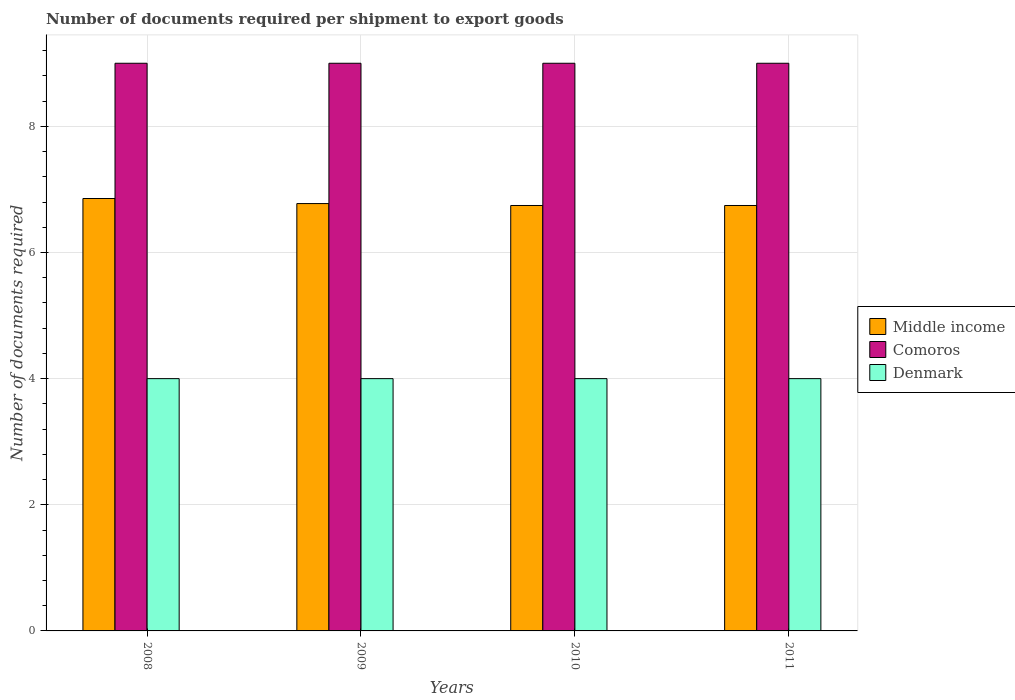How many different coloured bars are there?
Offer a very short reply. 3. How many groups of bars are there?
Ensure brevity in your answer.  4. Are the number of bars on each tick of the X-axis equal?
Ensure brevity in your answer.  Yes. How many bars are there on the 4th tick from the left?
Provide a succinct answer. 3. What is the label of the 1st group of bars from the left?
Your answer should be compact. 2008. What is the number of documents required per shipment to export goods in Denmark in 2009?
Provide a short and direct response. 4. Across all years, what is the maximum number of documents required per shipment to export goods in Middle income?
Your answer should be very brief. 6.86. Across all years, what is the minimum number of documents required per shipment to export goods in Denmark?
Your response must be concise. 4. In which year was the number of documents required per shipment to export goods in Middle income maximum?
Provide a succinct answer. 2008. What is the total number of documents required per shipment to export goods in Comoros in the graph?
Your answer should be very brief. 36. What is the difference between the number of documents required per shipment to export goods in Comoros in 2008 and the number of documents required per shipment to export goods in Denmark in 2009?
Your response must be concise. 5. What is the average number of documents required per shipment to export goods in Comoros per year?
Your response must be concise. 9. In the year 2009, what is the difference between the number of documents required per shipment to export goods in Middle income and number of documents required per shipment to export goods in Denmark?
Keep it short and to the point. 2.78. In how many years, is the number of documents required per shipment to export goods in Middle income greater than 2.4?
Your answer should be very brief. 4. What is the ratio of the number of documents required per shipment to export goods in Comoros in 2008 to that in 2009?
Your response must be concise. 1. What is the difference between the highest and the lowest number of documents required per shipment to export goods in Denmark?
Give a very brief answer. 0. What does the 1st bar from the right in 2011 represents?
Ensure brevity in your answer.  Denmark. How many bars are there?
Keep it short and to the point. 12. Are all the bars in the graph horizontal?
Offer a terse response. No. Are the values on the major ticks of Y-axis written in scientific E-notation?
Your response must be concise. No. How many legend labels are there?
Ensure brevity in your answer.  3. How are the legend labels stacked?
Offer a very short reply. Vertical. What is the title of the graph?
Provide a succinct answer. Number of documents required per shipment to export goods. What is the label or title of the Y-axis?
Ensure brevity in your answer.  Number of documents required. What is the Number of documents required in Middle income in 2008?
Keep it short and to the point. 6.86. What is the Number of documents required in Denmark in 2008?
Give a very brief answer. 4. What is the Number of documents required of Middle income in 2009?
Give a very brief answer. 6.78. What is the Number of documents required of Comoros in 2009?
Offer a terse response. 9. What is the Number of documents required of Denmark in 2009?
Ensure brevity in your answer.  4. What is the Number of documents required in Middle income in 2010?
Your answer should be very brief. 6.74. What is the Number of documents required of Comoros in 2010?
Provide a succinct answer. 9. What is the Number of documents required in Denmark in 2010?
Keep it short and to the point. 4. What is the Number of documents required of Middle income in 2011?
Provide a succinct answer. 6.74. Across all years, what is the maximum Number of documents required of Middle income?
Offer a terse response. 6.86. Across all years, what is the maximum Number of documents required in Comoros?
Offer a terse response. 9. Across all years, what is the minimum Number of documents required in Middle income?
Provide a succinct answer. 6.74. Across all years, what is the minimum Number of documents required of Denmark?
Offer a terse response. 4. What is the total Number of documents required of Middle income in the graph?
Provide a succinct answer. 27.12. What is the difference between the Number of documents required of Middle income in 2008 and that in 2009?
Keep it short and to the point. 0.08. What is the difference between the Number of documents required in Middle income in 2008 and that in 2010?
Offer a very short reply. 0.11. What is the difference between the Number of documents required in Comoros in 2008 and that in 2010?
Your answer should be compact. 0. What is the difference between the Number of documents required of Middle income in 2008 and that in 2011?
Make the answer very short. 0.11. What is the difference between the Number of documents required in Comoros in 2008 and that in 2011?
Your response must be concise. 0. What is the difference between the Number of documents required of Denmark in 2008 and that in 2011?
Keep it short and to the point. 0. What is the difference between the Number of documents required in Middle income in 2009 and that in 2010?
Your answer should be very brief. 0.03. What is the difference between the Number of documents required of Denmark in 2009 and that in 2010?
Ensure brevity in your answer.  0. What is the difference between the Number of documents required of Middle income in 2009 and that in 2011?
Keep it short and to the point. 0.03. What is the difference between the Number of documents required of Denmark in 2010 and that in 2011?
Make the answer very short. 0. What is the difference between the Number of documents required in Middle income in 2008 and the Number of documents required in Comoros in 2009?
Offer a very short reply. -2.14. What is the difference between the Number of documents required in Middle income in 2008 and the Number of documents required in Denmark in 2009?
Offer a very short reply. 2.86. What is the difference between the Number of documents required of Middle income in 2008 and the Number of documents required of Comoros in 2010?
Offer a very short reply. -2.14. What is the difference between the Number of documents required in Middle income in 2008 and the Number of documents required in Denmark in 2010?
Provide a short and direct response. 2.86. What is the difference between the Number of documents required in Middle income in 2008 and the Number of documents required in Comoros in 2011?
Your answer should be compact. -2.14. What is the difference between the Number of documents required in Middle income in 2008 and the Number of documents required in Denmark in 2011?
Provide a succinct answer. 2.86. What is the difference between the Number of documents required in Comoros in 2008 and the Number of documents required in Denmark in 2011?
Make the answer very short. 5. What is the difference between the Number of documents required of Middle income in 2009 and the Number of documents required of Comoros in 2010?
Offer a terse response. -2.22. What is the difference between the Number of documents required in Middle income in 2009 and the Number of documents required in Denmark in 2010?
Offer a terse response. 2.78. What is the difference between the Number of documents required in Comoros in 2009 and the Number of documents required in Denmark in 2010?
Provide a short and direct response. 5. What is the difference between the Number of documents required in Middle income in 2009 and the Number of documents required in Comoros in 2011?
Your answer should be very brief. -2.22. What is the difference between the Number of documents required of Middle income in 2009 and the Number of documents required of Denmark in 2011?
Give a very brief answer. 2.78. What is the difference between the Number of documents required of Comoros in 2009 and the Number of documents required of Denmark in 2011?
Offer a terse response. 5. What is the difference between the Number of documents required in Middle income in 2010 and the Number of documents required in Comoros in 2011?
Keep it short and to the point. -2.26. What is the difference between the Number of documents required of Middle income in 2010 and the Number of documents required of Denmark in 2011?
Make the answer very short. 2.74. What is the difference between the Number of documents required in Comoros in 2010 and the Number of documents required in Denmark in 2011?
Offer a very short reply. 5. What is the average Number of documents required in Middle income per year?
Provide a short and direct response. 6.78. What is the average Number of documents required of Comoros per year?
Provide a short and direct response. 9. In the year 2008, what is the difference between the Number of documents required in Middle income and Number of documents required in Comoros?
Make the answer very short. -2.14. In the year 2008, what is the difference between the Number of documents required in Middle income and Number of documents required in Denmark?
Provide a succinct answer. 2.86. In the year 2009, what is the difference between the Number of documents required in Middle income and Number of documents required in Comoros?
Make the answer very short. -2.22. In the year 2009, what is the difference between the Number of documents required of Middle income and Number of documents required of Denmark?
Keep it short and to the point. 2.78. In the year 2010, what is the difference between the Number of documents required of Middle income and Number of documents required of Comoros?
Your answer should be very brief. -2.26. In the year 2010, what is the difference between the Number of documents required of Middle income and Number of documents required of Denmark?
Give a very brief answer. 2.74. In the year 2010, what is the difference between the Number of documents required of Comoros and Number of documents required of Denmark?
Your answer should be compact. 5. In the year 2011, what is the difference between the Number of documents required of Middle income and Number of documents required of Comoros?
Offer a terse response. -2.26. In the year 2011, what is the difference between the Number of documents required in Middle income and Number of documents required in Denmark?
Provide a short and direct response. 2.74. In the year 2011, what is the difference between the Number of documents required in Comoros and Number of documents required in Denmark?
Offer a very short reply. 5. What is the ratio of the Number of documents required in Middle income in 2008 to that in 2009?
Make the answer very short. 1.01. What is the ratio of the Number of documents required in Comoros in 2008 to that in 2009?
Your answer should be very brief. 1. What is the ratio of the Number of documents required of Denmark in 2008 to that in 2009?
Make the answer very short. 1. What is the ratio of the Number of documents required of Middle income in 2008 to that in 2010?
Keep it short and to the point. 1.02. What is the ratio of the Number of documents required in Comoros in 2008 to that in 2010?
Offer a very short reply. 1. What is the ratio of the Number of documents required in Denmark in 2008 to that in 2010?
Your answer should be compact. 1. What is the ratio of the Number of documents required of Middle income in 2008 to that in 2011?
Your answer should be compact. 1.02. What is the ratio of the Number of documents required in Comoros in 2008 to that in 2011?
Your answer should be compact. 1. What is the ratio of the Number of documents required in Denmark in 2008 to that in 2011?
Give a very brief answer. 1. What is the ratio of the Number of documents required of Comoros in 2009 to that in 2010?
Offer a terse response. 1. What is the ratio of the Number of documents required of Denmark in 2009 to that in 2010?
Provide a short and direct response. 1. What is the ratio of the Number of documents required in Middle income in 2009 to that in 2011?
Your answer should be very brief. 1. What is the ratio of the Number of documents required of Comoros in 2009 to that in 2011?
Ensure brevity in your answer.  1. What is the ratio of the Number of documents required of Middle income in 2010 to that in 2011?
Keep it short and to the point. 1. What is the ratio of the Number of documents required of Comoros in 2010 to that in 2011?
Make the answer very short. 1. What is the difference between the highest and the second highest Number of documents required in Middle income?
Your answer should be very brief. 0.08. What is the difference between the highest and the second highest Number of documents required of Denmark?
Your answer should be compact. 0. What is the difference between the highest and the lowest Number of documents required of Middle income?
Provide a succinct answer. 0.11. What is the difference between the highest and the lowest Number of documents required in Comoros?
Keep it short and to the point. 0. 